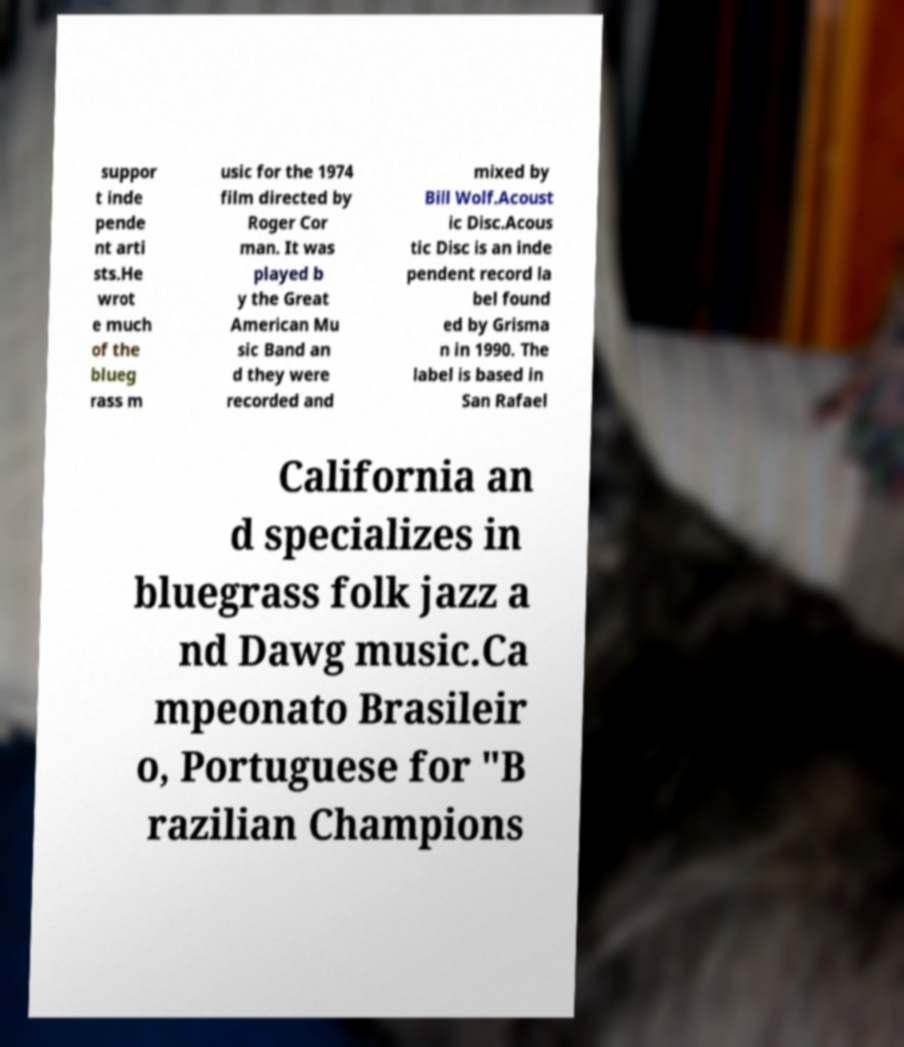Could you assist in decoding the text presented in this image and type it out clearly? suppor t inde pende nt arti sts.He wrot e much of the blueg rass m usic for the 1974 film directed by Roger Cor man. It was played b y the Great American Mu sic Band an d they were recorded and mixed by Bill Wolf.Acoust ic Disc.Acous tic Disc is an inde pendent record la bel found ed by Grisma n in 1990. The label is based in San Rafael California an d specializes in bluegrass folk jazz a nd Dawg music.Ca mpeonato Brasileir o, Portuguese for "B razilian Champions 